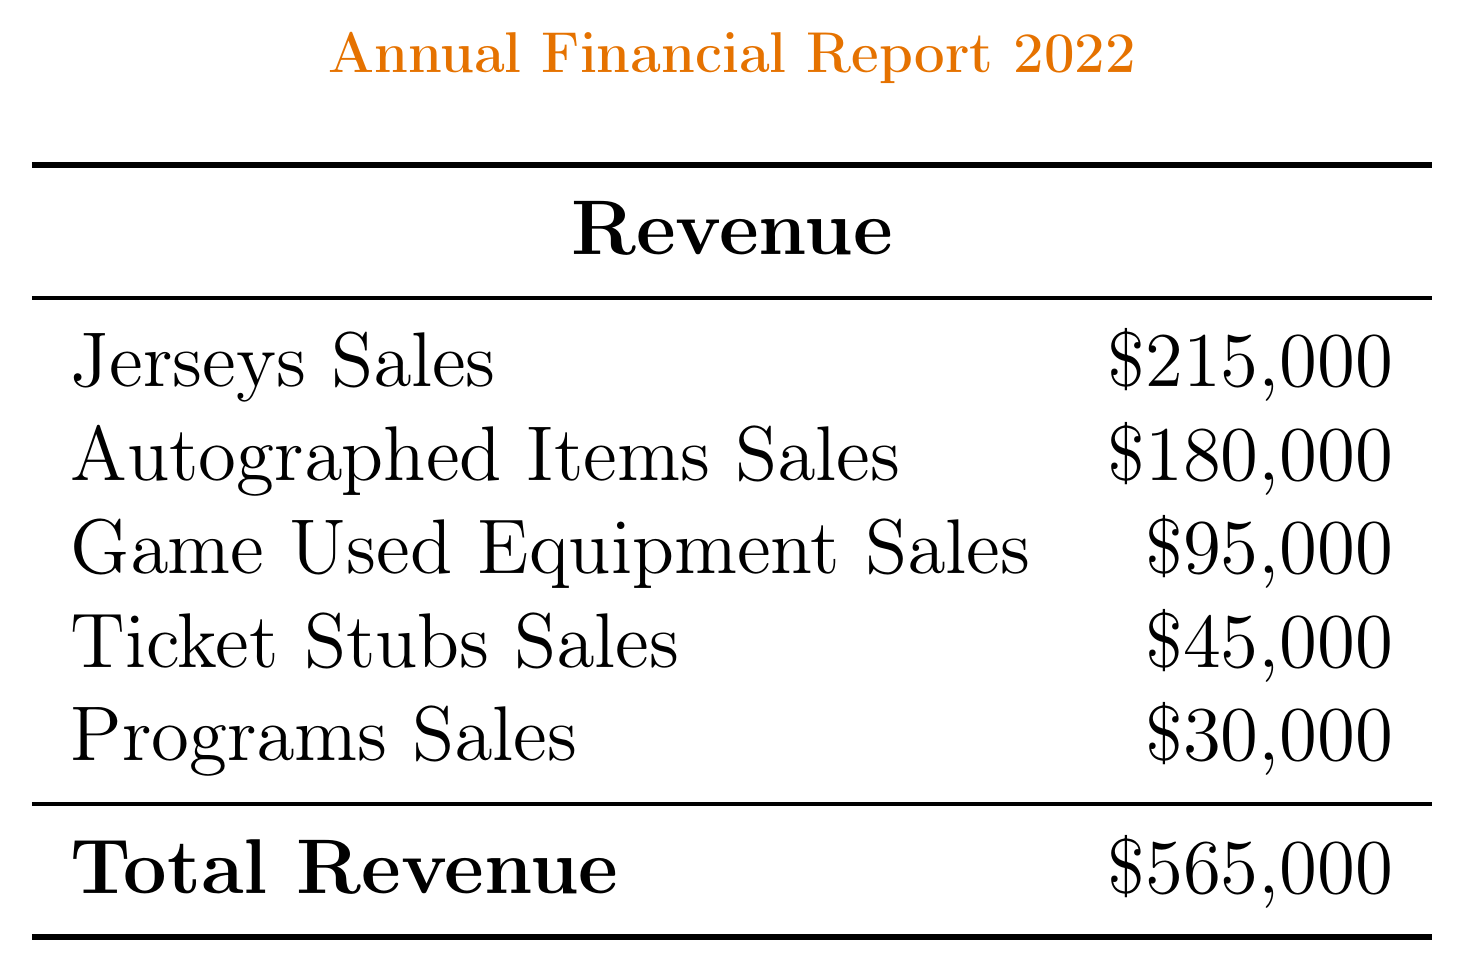what is the total revenue? The total revenue is the sum of all revenue sources in the document, which is $215,000 + $180,000 + $95,000 + $45,000 + $30,000 = $565,000.
Answer: $565,000 what is the net profit? The net profit is calculated by subtracting total expenses from total revenue, which is $565,000 - $557,500 = $29,500.
Answer: $29,500 what was the most profitable category? The most profitable category is the one with the highest profit margin, which is explicitly stated in the document.
Answer: Autographed Items what was the year-over-year growth percentage? The year-over-year growth percentage is provided in the key metrics section, reflecting how much the business has grown compared to the previous year.
Answer: 8.5% what was the special promotion for the year? The document lists notable events, including promotions and partnerships related to the business.
Answer: 25th Anniversary Sharks Team Signed Stick what is the total expenses amount? The total expenses can be found by summing all individual expense items listed in the document, which totals $557,500.
Answer: $557,500 who is the top-selling item associated with? The top-selling item is specified in the key metrics section, identifying the popular item among customers.
Answer: Joe Thornton Autographed Jersey what is the loan interest expense? The loan interest expense is specifically noted in the list of other expenses in the document.
Answer: $7,500 what is the total cost of goods sold? The total cost of goods sold is the sum of merchandise purchases and shipping and handling, which equals $310,000.
Answer: $310,000 